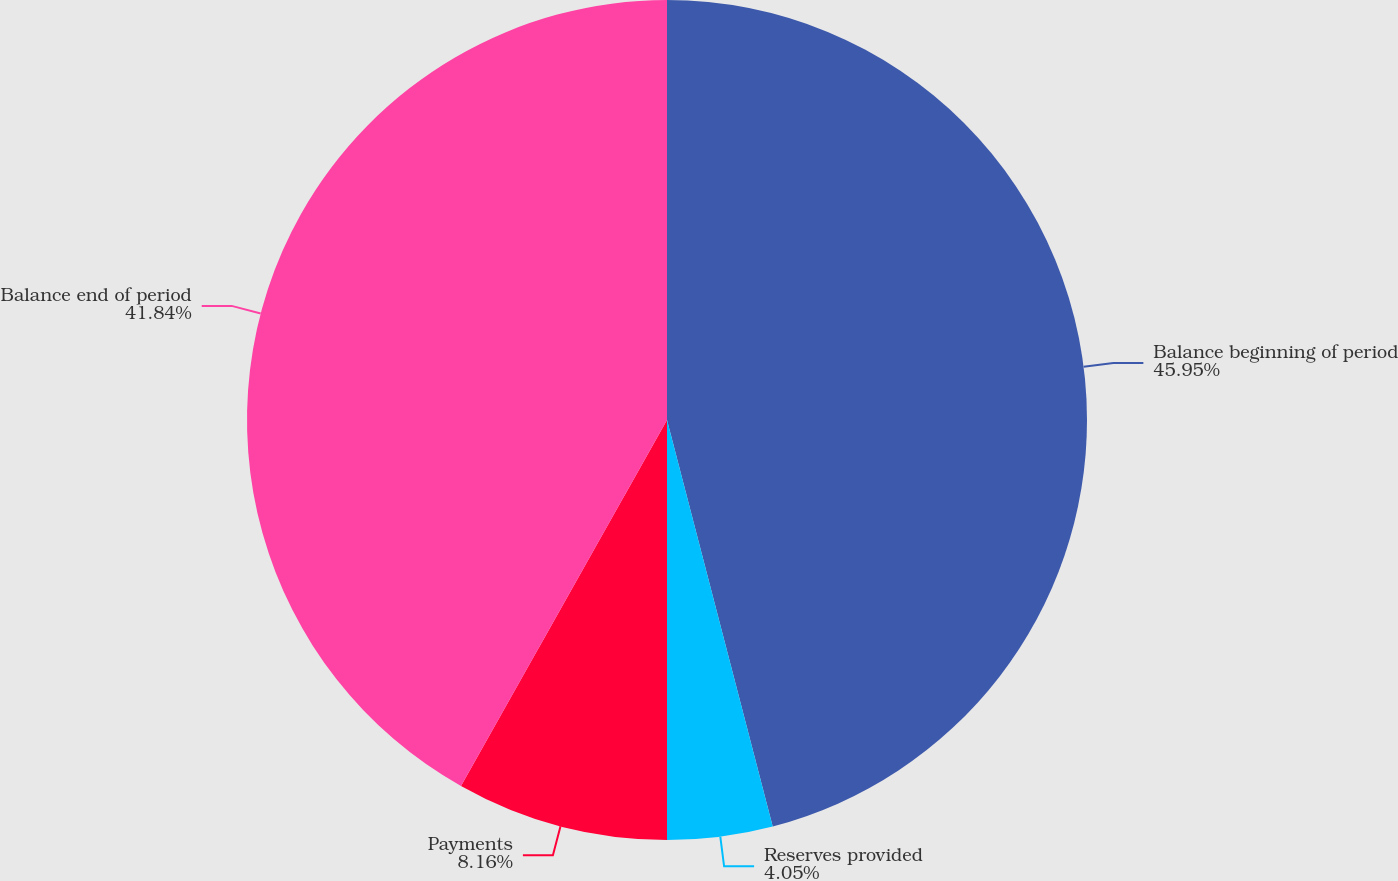<chart> <loc_0><loc_0><loc_500><loc_500><pie_chart><fcel>Balance beginning of period<fcel>Reserves provided<fcel>Payments<fcel>Balance end of period<nl><fcel>45.95%<fcel>4.05%<fcel>8.16%<fcel>41.84%<nl></chart> 